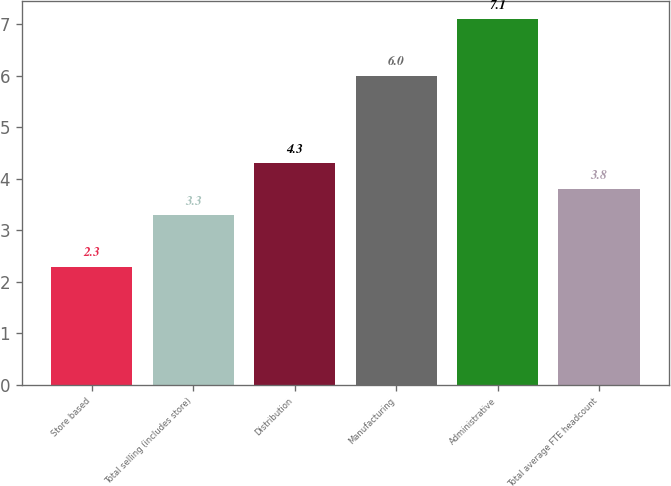Convert chart. <chart><loc_0><loc_0><loc_500><loc_500><bar_chart><fcel>Store based<fcel>Total selling (includes store)<fcel>Distribution<fcel>Manufacturing<fcel>Administrative<fcel>Total average FTE headcount<nl><fcel>2.3<fcel>3.3<fcel>4.3<fcel>6<fcel>7.1<fcel>3.8<nl></chart> 